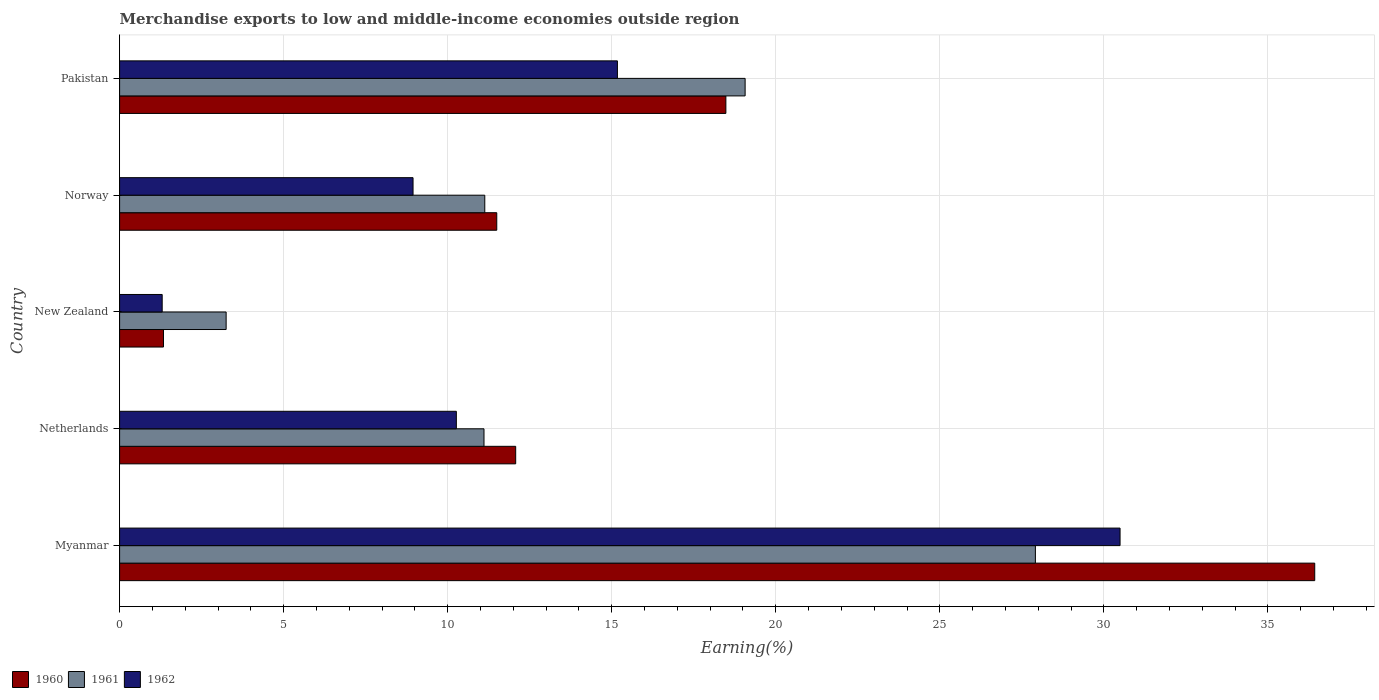How many different coloured bars are there?
Keep it short and to the point. 3. How many groups of bars are there?
Provide a short and direct response. 5. Are the number of bars per tick equal to the number of legend labels?
Your response must be concise. Yes. Are the number of bars on each tick of the Y-axis equal?
Make the answer very short. Yes. How many bars are there on the 4th tick from the bottom?
Keep it short and to the point. 3. In how many cases, is the number of bars for a given country not equal to the number of legend labels?
Provide a succinct answer. 0. What is the percentage of amount earned from merchandise exports in 1962 in Netherlands?
Your response must be concise. 10.26. Across all countries, what is the maximum percentage of amount earned from merchandise exports in 1962?
Provide a succinct answer. 30.49. Across all countries, what is the minimum percentage of amount earned from merchandise exports in 1962?
Give a very brief answer. 1.3. In which country was the percentage of amount earned from merchandise exports in 1961 maximum?
Make the answer very short. Myanmar. In which country was the percentage of amount earned from merchandise exports in 1961 minimum?
Offer a terse response. New Zealand. What is the total percentage of amount earned from merchandise exports in 1961 in the graph?
Your answer should be compact. 72.46. What is the difference between the percentage of amount earned from merchandise exports in 1962 in Netherlands and that in New Zealand?
Ensure brevity in your answer.  8.97. What is the difference between the percentage of amount earned from merchandise exports in 1962 in New Zealand and the percentage of amount earned from merchandise exports in 1961 in Myanmar?
Your answer should be compact. -26.61. What is the average percentage of amount earned from merchandise exports in 1961 per country?
Your response must be concise. 14.49. What is the difference between the percentage of amount earned from merchandise exports in 1961 and percentage of amount earned from merchandise exports in 1960 in Norway?
Provide a short and direct response. -0.37. What is the ratio of the percentage of amount earned from merchandise exports in 1962 in Netherlands to that in New Zealand?
Provide a succinct answer. 7.91. Is the difference between the percentage of amount earned from merchandise exports in 1961 in Myanmar and Pakistan greater than the difference between the percentage of amount earned from merchandise exports in 1960 in Myanmar and Pakistan?
Keep it short and to the point. No. What is the difference between the highest and the second highest percentage of amount earned from merchandise exports in 1961?
Your answer should be compact. 8.85. What is the difference between the highest and the lowest percentage of amount earned from merchandise exports in 1962?
Offer a very short reply. 29.2. Is the sum of the percentage of amount earned from merchandise exports in 1961 in Myanmar and Pakistan greater than the maximum percentage of amount earned from merchandise exports in 1960 across all countries?
Your answer should be compact. Yes. What does the 1st bar from the top in Norway represents?
Keep it short and to the point. 1962. What does the 1st bar from the bottom in Netherlands represents?
Keep it short and to the point. 1960. Is it the case that in every country, the sum of the percentage of amount earned from merchandise exports in 1961 and percentage of amount earned from merchandise exports in 1962 is greater than the percentage of amount earned from merchandise exports in 1960?
Your answer should be compact. Yes. Are all the bars in the graph horizontal?
Provide a succinct answer. Yes. How many countries are there in the graph?
Make the answer very short. 5. What is the difference between two consecutive major ticks on the X-axis?
Your response must be concise. 5. Are the values on the major ticks of X-axis written in scientific E-notation?
Offer a very short reply. No. Does the graph contain any zero values?
Offer a very short reply. No. Where does the legend appear in the graph?
Your answer should be very brief. Bottom left. How many legend labels are there?
Provide a short and direct response. 3. What is the title of the graph?
Your answer should be compact. Merchandise exports to low and middle-income economies outside region. Does "1989" appear as one of the legend labels in the graph?
Give a very brief answer. No. What is the label or title of the X-axis?
Give a very brief answer. Earning(%). What is the Earning(%) in 1960 in Myanmar?
Your answer should be compact. 36.43. What is the Earning(%) in 1961 in Myanmar?
Offer a very short reply. 27.91. What is the Earning(%) of 1962 in Myanmar?
Provide a succinct answer. 30.49. What is the Earning(%) of 1960 in Netherlands?
Keep it short and to the point. 12.07. What is the Earning(%) in 1961 in Netherlands?
Your answer should be very brief. 11.11. What is the Earning(%) in 1962 in Netherlands?
Your answer should be very brief. 10.26. What is the Earning(%) of 1960 in New Zealand?
Offer a terse response. 1.34. What is the Earning(%) of 1961 in New Zealand?
Keep it short and to the point. 3.25. What is the Earning(%) of 1962 in New Zealand?
Offer a terse response. 1.3. What is the Earning(%) of 1960 in Norway?
Your answer should be compact. 11.5. What is the Earning(%) of 1961 in Norway?
Ensure brevity in your answer.  11.13. What is the Earning(%) in 1962 in Norway?
Your answer should be compact. 8.94. What is the Earning(%) of 1960 in Pakistan?
Provide a succinct answer. 18.48. What is the Earning(%) of 1961 in Pakistan?
Your answer should be very brief. 19.07. What is the Earning(%) in 1962 in Pakistan?
Your answer should be very brief. 15.17. Across all countries, what is the maximum Earning(%) in 1960?
Provide a succinct answer. 36.43. Across all countries, what is the maximum Earning(%) of 1961?
Your response must be concise. 27.91. Across all countries, what is the maximum Earning(%) of 1962?
Your answer should be compact. 30.49. Across all countries, what is the minimum Earning(%) of 1960?
Ensure brevity in your answer.  1.34. Across all countries, what is the minimum Earning(%) of 1961?
Your answer should be very brief. 3.25. Across all countries, what is the minimum Earning(%) of 1962?
Provide a succinct answer. 1.3. What is the total Earning(%) in 1960 in the graph?
Provide a succinct answer. 79.81. What is the total Earning(%) of 1961 in the graph?
Your response must be concise. 72.46. What is the total Earning(%) of 1962 in the graph?
Your response must be concise. 66.17. What is the difference between the Earning(%) in 1960 in Myanmar and that in Netherlands?
Your answer should be very brief. 24.35. What is the difference between the Earning(%) of 1961 in Myanmar and that in Netherlands?
Provide a short and direct response. 16.81. What is the difference between the Earning(%) in 1962 in Myanmar and that in Netherlands?
Provide a short and direct response. 20.23. What is the difference between the Earning(%) of 1960 in Myanmar and that in New Zealand?
Your answer should be very brief. 35.09. What is the difference between the Earning(%) of 1961 in Myanmar and that in New Zealand?
Offer a very short reply. 24.67. What is the difference between the Earning(%) of 1962 in Myanmar and that in New Zealand?
Give a very brief answer. 29.2. What is the difference between the Earning(%) in 1960 in Myanmar and that in Norway?
Ensure brevity in your answer.  24.93. What is the difference between the Earning(%) in 1961 in Myanmar and that in Norway?
Make the answer very short. 16.78. What is the difference between the Earning(%) in 1962 in Myanmar and that in Norway?
Offer a very short reply. 21.55. What is the difference between the Earning(%) of 1960 in Myanmar and that in Pakistan?
Your answer should be compact. 17.95. What is the difference between the Earning(%) in 1961 in Myanmar and that in Pakistan?
Your answer should be very brief. 8.85. What is the difference between the Earning(%) in 1962 in Myanmar and that in Pakistan?
Your answer should be compact. 15.32. What is the difference between the Earning(%) in 1960 in Netherlands and that in New Zealand?
Provide a short and direct response. 10.73. What is the difference between the Earning(%) of 1961 in Netherlands and that in New Zealand?
Offer a very short reply. 7.86. What is the difference between the Earning(%) of 1962 in Netherlands and that in New Zealand?
Provide a short and direct response. 8.97. What is the difference between the Earning(%) of 1960 in Netherlands and that in Norway?
Keep it short and to the point. 0.58. What is the difference between the Earning(%) in 1961 in Netherlands and that in Norway?
Your answer should be very brief. -0.02. What is the difference between the Earning(%) of 1962 in Netherlands and that in Norway?
Offer a terse response. 1.32. What is the difference between the Earning(%) in 1960 in Netherlands and that in Pakistan?
Provide a succinct answer. -6.41. What is the difference between the Earning(%) of 1961 in Netherlands and that in Pakistan?
Provide a short and direct response. -7.96. What is the difference between the Earning(%) of 1962 in Netherlands and that in Pakistan?
Your response must be concise. -4.91. What is the difference between the Earning(%) in 1960 in New Zealand and that in Norway?
Give a very brief answer. -10.16. What is the difference between the Earning(%) of 1961 in New Zealand and that in Norway?
Offer a terse response. -7.88. What is the difference between the Earning(%) in 1962 in New Zealand and that in Norway?
Your answer should be very brief. -7.65. What is the difference between the Earning(%) in 1960 in New Zealand and that in Pakistan?
Ensure brevity in your answer.  -17.14. What is the difference between the Earning(%) in 1961 in New Zealand and that in Pakistan?
Offer a terse response. -15.82. What is the difference between the Earning(%) in 1962 in New Zealand and that in Pakistan?
Offer a terse response. -13.88. What is the difference between the Earning(%) in 1960 in Norway and that in Pakistan?
Make the answer very short. -6.98. What is the difference between the Earning(%) in 1961 in Norway and that in Pakistan?
Offer a very short reply. -7.94. What is the difference between the Earning(%) in 1962 in Norway and that in Pakistan?
Your answer should be very brief. -6.23. What is the difference between the Earning(%) of 1960 in Myanmar and the Earning(%) of 1961 in Netherlands?
Make the answer very short. 25.32. What is the difference between the Earning(%) of 1960 in Myanmar and the Earning(%) of 1962 in Netherlands?
Offer a terse response. 26.16. What is the difference between the Earning(%) of 1961 in Myanmar and the Earning(%) of 1962 in Netherlands?
Give a very brief answer. 17.65. What is the difference between the Earning(%) of 1960 in Myanmar and the Earning(%) of 1961 in New Zealand?
Provide a succinct answer. 33.18. What is the difference between the Earning(%) in 1960 in Myanmar and the Earning(%) in 1962 in New Zealand?
Your response must be concise. 35.13. What is the difference between the Earning(%) in 1961 in Myanmar and the Earning(%) in 1962 in New Zealand?
Provide a succinct answer. 26.61. What is the difference between the Earning(%) in 1960 in Myanmar and the Earning(%) in 1961 in Norway?
Make the answer very short. 25.3. What is the difference between the Earning(%) of 1960 in Myanmar and the Earning(%) of 1962 in Norway?
Your response must be concise. 27.48. What is the difference between the Earning(%) in 1961 in Myanmar and the Earning(%) in 1962 in Norway?
Your answer should be very brief. 18.97. What is the difference between the Earning(%) in 1960 in Myanmar and the Earning(%) in 1961 in Pakistan?
Keep it short and to the point. 17.36. What is the difference between the Earning(%) in 1960 in Myanmar and the Earning(%) in 1962 in Pakistan?
Offer a terse response. 21.25. What is the difference between the Earning(%) of 1961 in Myanmar and the Earning(%) of 1962 in Pakistan?
Your answer should be compact. 12.74. What is the difference between the Earning(%) in 1960 in Netherlands and the Earning(%) in 1961 in New Zealand?
Your answer should be very brief. 8.83. What is the difference between the Earning(%) in 1960 in Netherlands and the Earning(%) in 1962 in New Zealand?
Give a very brief answer. 10.77. What is the difference between the Earning(%) of 1961 in Netherlands and the Earning(%) of 1962 in New Zealand?
Offer a very short reply. 9.81. What is the difference between the Earning(%) in 1960 in Netherlands and the Earning(%) in 1961 in Norway?
Your answer should be very brief. 0.94. What is the difference between the Earning(%) of 1960 in Netherlands and the Earning(%) of 1962 in Norway?
Provide a short and direct response. 3.13. What is the difference between the Earning(%) in 1961 in Netherlands and the Earning(%) in 1962 in Norway?
Make the answer very short. 2.16. What is the difference between the Earning(%) of 1960 in Netherlands and the Earning(%) of 1961 in Pakistan?
Ensure brevity in your answer.  -6.99. What is the difference between the Earning(%) in 1960 in Netherlands and the Earning(%) in 1962 in Pakistan?
Give a very brief answer. -3.1. What is the difference between the Earning(%) of 1961 in Netherlands and the Earning(%) of 1962 in Pakistan?
Your response must be concise. -4.07. What is the difference between the Earning(%) in 1960 in New Zealand and the Earning(%) in 1961 in Norway?
Your answer should be very brief. -9.79. What is the difference between the Earning(%) in 1960 in New Zealand and the Earning(%) in 1962 in Norway?
Make the answer very short. -7.61. What is the difference between the Earning(%) in 1961 in New Zealand and the Earning(%) in 1962 in Norway?
Your answer should be very brief. -5.7. What is the difference between the Earning(%) in 1960 in New Zealand and the Earning(%) in 1961 in Pakistan?
Your answer should be compact. -17.73. What is the difference between the Earning(%) of 1960 in New Zealand and the Earning(%) of 1962 in Pakistan?
Your response must be concise. -13.84. What is the difference between the Earning(%) of 1961 in New Zealand and the Earning(%) of 1962 in Pakistan?
Provide a short and direct response. -11.93. What is the difference between the Earning(%) in 1960 in Norway and the Earning(%) in 1961 in Pakistan?
Offer a very short reply. -7.57. What is the difference between the Earning(%) in 1960 in Norway and the Earning(%) in 1962 in Pakistan?
Offer a terse response. -3.68. What is the difference between the Earning(%) in 1961 in Norway and the Earning(%) in 1962 in Pakistan?
Make the answer very short. -4.04. What is the average Earning(%) of 1960 per country?
Provide a succinct answer. 15.96. What is the average Earning(%) in 1961 per country?
Give a very brief answer. 14.49. What is the average Earning(%) in 1962 per country?
Keep it short and to the point. 13.23. What is the difference between the Earning(%) of 1960 and Earning(%) of 1961 in Myanmar?
Offer a terse response. 8.51. What is the difference between the Earning(%) in 1960 and Earning(%) in 1962 in Myanmar?
Give a very brief answer. 5.93. What is the difference between the Earning(%) of 1961 and Earning(%) of 1962 in Myanmar?
Ensure brevity in your answer.  -2.58. What is the difference between the Earning(%) of 1960 and Earning(%) of 1961 in Netherlands?
Your response must be concise. 0.97. What is the difference between the Earning(%) of 1960 and Earning(%) of 1962 in Netherlands?
Provide a short and direct response. 1.81. What is the difference between the Earning(%) of 1961 and Earning(%) of 1962 in Netherlands?
Give a very brief answer. 0.84. What is the difference between the Earning(%) in 1960 and Earning(%) in 1961 in New Zealand?
Keep it short and to the point. -1.91. What is the difference between the Earning(%) in 1960 and Earning(%) in 1962 in New Zealand?
Your answer should be very brief. 0.04. What is the difference between the Earning(%) in 1961 and Earning(%) in 1962 in New Zealand?
Keep it short and to the point. 1.95. What is the difference between the Earning(%) of 1960 and Earning(%) of 1961 in Norway?
Your answer should be very brief. 0.37. What is the difference between the Earning(%) in 1960 and Earning(%) in 1962 in Norway?
Offer a very short reply. 2.55. What is the difference between the Earning(%) in 1961 and Earning(%) in 1962 in Norway?
Provide a short and direct response. 2.19. What is the difference between the Earning(%) in 1960 and Earning(%) in 1961 in Pakistan?
Your answer should be compact. -0.59. What is the difference between the Earning(%) in 1960 and Earning(%) in 1962 in Pakistan?
Your answer should be compact. 3.31. What is the difference between the Earning(%) of 1961 and Earning(%) of 1962 in Pakistan?
Provide a succinct answer. 3.89. What is the ratio of the Earning(%) in 1960 in Myanmar to that in Netherlands?
Keep it short and to the point. 3.02. What is the ratio of the Earning(%) in 1961 in Myanmar to that in Netherlands?
Your answer should be compact. 2.51. What is the ratio of the Earning(%) in 1962 in Myanmar to that in Netherlands?
Offer a terse response. 2.97. What is the ratio of the Earning(%) in 1960 in Myanmar to that in New Zealand?
Your answer should be very brief. 27.24. What is the ratio of the Earning(%) of 1961 in Myanmar to that in New Zealand?
Offer a very short reply. 8.6. What is the ratio of the Earning(%) in 1962 in Myanmar to that in New Zealand?
Your response must be concise. 23.5. What is the ratio of the Earning(%) of 1960 in Myanmar to that in Norway?
Your response must be concise. 3.17. What is the ratio of the Earning(%) of 1961 in Myanmar to that in Norway?
Offer a terse response. 2.51. What is the ratio of the Earning(%) of 1962 in Myanmar to that in Norway?
Ensure brevity in your answer.  3.41. What is the ratio of the Earning(%) in 1960 in Myanmar to that in Pakistan?
Offer a terse response. 1.97. What is the ratio of the Earning(%) of 1961 in Myanmar to that in Pakistan?
Provide a succinct answer. 1.46. What is the ratio of the Earning(%) in 1962 in Myanmar to that in Pakistan?
Your answer should be compact. 2.01. What is the ratio of the Earning(%) in 1960 in Netherlands to that in New Zealand?
Provide a succinct answer. 9.03. What is the ratio of the Earning(%) in 1961 in Netherlands to that in New Zealand?
Make the answer very short. 3.42. What is the ratio of the Earning(%) of 1962 in Netherlands to that in New Zealand?
Provide a short and direct response. 7.91. What is the ratio of the Earning(%) in 1960 in Netherlands to that in Norway?
Keep it short and to the point. 1.05. What is the ratio of the Earning(%) in 1962 in Netherlands to that in Norway?
Make the answer very short. 1.15. What is the ratio of the Earning(%) of 1960 in Netherlands to that in Pakistan?
Provide a short and direct response. 0.65. What is the ratio of the Earning(%) in 1961 in Netherlands to that in Pakistan?
Your answer should be very brief. 0.58. What is the ratio of the Earning(%) in 1962 in Netherlands to that in Pakistan?
Your answer should be very brief. 0.68. What is the ratio of the Earning(%) in 1960 in New Zealand to that in Norway?
Offer a terse response. 0.12. What is the ratio of the Earning(%) of 1961 in New Zealand to that in Norway?
Your response must be concise. 0.29. What is the ratio of the Earning(%) in 1962 in New Zealand to that in Norway?
Ensure brevity in your answer.  0.15. What is the ratio of the Earning(%) in 1960 in New Zealand to that in Pakistan?
Provide a succinct answer. 0.07. What is the ratio of the Earning(%) in 1961 in New Zealand to that in Pakistan?
Provide a short and direct response. 0.17. What is the ratio of the Earning(%) of 1962 in New Zealand to that in Pakistan?
Make the answer very short. 0.09. What is the ratio of the Earning(%) in 1960 in Norway to that in Pakistan?
Offer a terse response. 0.62. What is the ratio of the Earning(%) in 1961 in Norway to that in Pakistan?
Keep it short and to the point. 0.58. What is the ratio of the Earning(%) in 1962 in Norway to that in Pakistan?
Keep it short and to the point. 0.59. What is the difference between the highest and the second highest Earning(%) in 1960?
Offer a terse response. 17.95. What is the difference between the highest and the second highest Earning(%) of 1961?
Keep it short and to the point. 8.85. What is the difference between the highest and the second highest Earning(%) of 1962?
Your answer should be compact. 15.32. What is the difference between the highest and the lowest Earning(%) of 1960?
Give a very brief answer. 35.09. What is the difference between the highest and the lowest Earning(%) of 1961?
Your answer should be compact. 24.67. What is the difference between the highest and the lowest Earning(%) of 1962?
Ensure brevity in your answer.  29.2. 